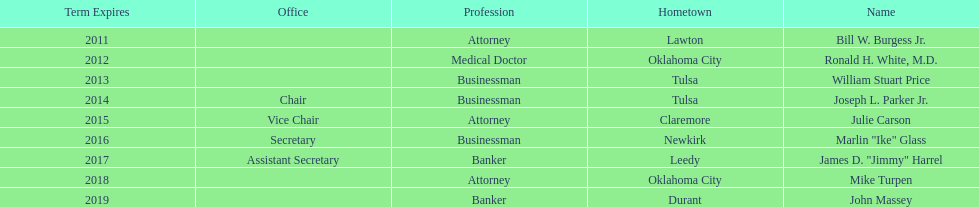How many of the current state regents have a listed office title? 4. 